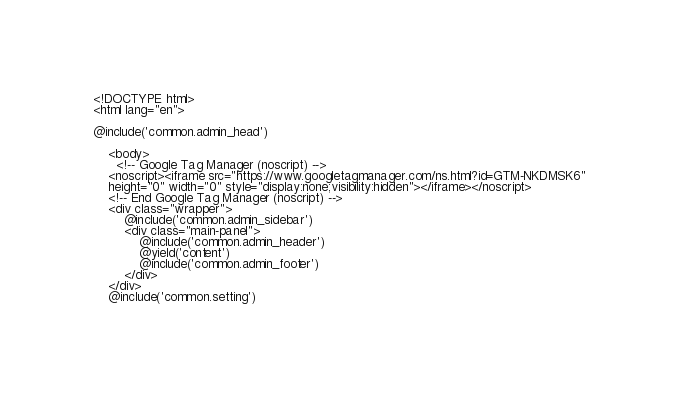<code> <loc_0><loc_0><loc_500><loc_500><_PHP_>
<!DOCTYPE html>
<html lang="en">

@include('common.admin_head')

    <body>
      <!-- Google Tag Manager (noscript) -->
    <noscript><iframe src="https://www.googletagmanager.com/ns.html?id=GTM-NKDMSK6"
    height="0" width="0" style="display:none;visibility:hidden"></iframe></noscript>
    <!-- End Google Tag Manager (noscript) -->
    <div class="wrapper">
        @include('common.admin_sidebar')
        <div class="main-panel">
            @include('common.admin_header')
            @yield('content')
            @include('common.admin_footer')
        </div>
    </div>
    @include('common.setting')</code> 